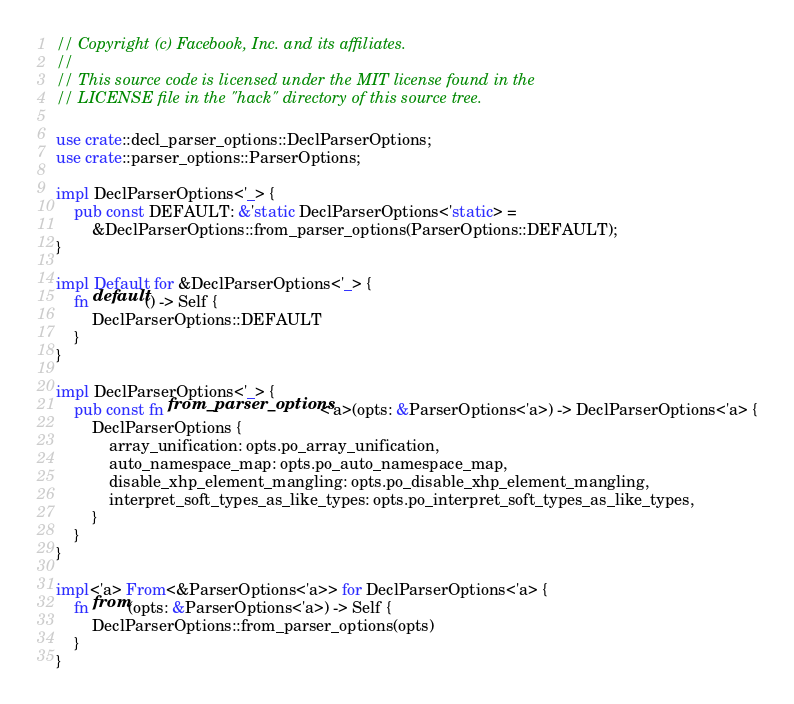Convert code to text. <code><loc_0><loc_0><loc_500><loc_500><_Rust_>// Copyright (c) Facebook, Inc. and its affiliates.
//
// This source code is licensed under the MIT license found in the
// LICENSE file in the "hack" directory of this source tree.

use crate::decl_parser_options::DeclParserOptions;
use crate::parser_options::ParserOptions;

impl DeclParserOptions<'_> {
    pub const DEFAULT: &'static DeclParserOptions<'static> =
        &DeclParserOptions::from_parser_options(ParserOptions::DEFAULT);
}

impl Default for &DeclParserOptions<'_> {
    fn default() -> Self {
        DeclParserOptions::DEFAULT
    }
}

impl DeclParserOptions<'_> {
    pub const fn from_parser_options<'a>(opts: &ParserOptions<'a>) -> DeclParserOptions<'a> {
        DeclParserOptions {
            array_unification: opts.po_array_unification,
            auto_namespace_map: opts.po_auto_namespace_map,
            disable_xhp_element_mangling: opts.po_disable_xhp_element_mangling,
            interpret_soft_types_as_like_types: opts.po_interpret_soft_types_as_like_types,
        }
    }
}

impl<'a> From<&ParserOptions<'a>> for DeclParserOptions<'a> {
    fn from(opts: &ParserOptions<'a>) -> Self {
        DeclParserOptions::from_parser_options(opts)
    }
}
</code> 